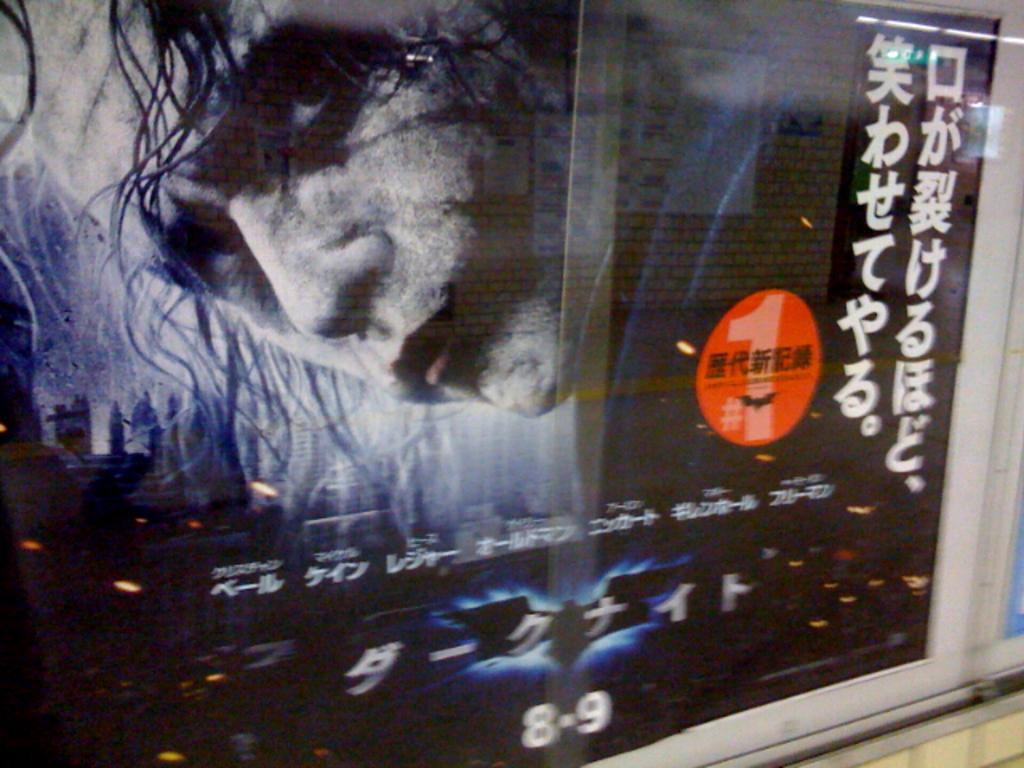<image>
Give a short and clear explanation of the subsequent image. Movie poster on a screen that has the numbers 8 and 9. 